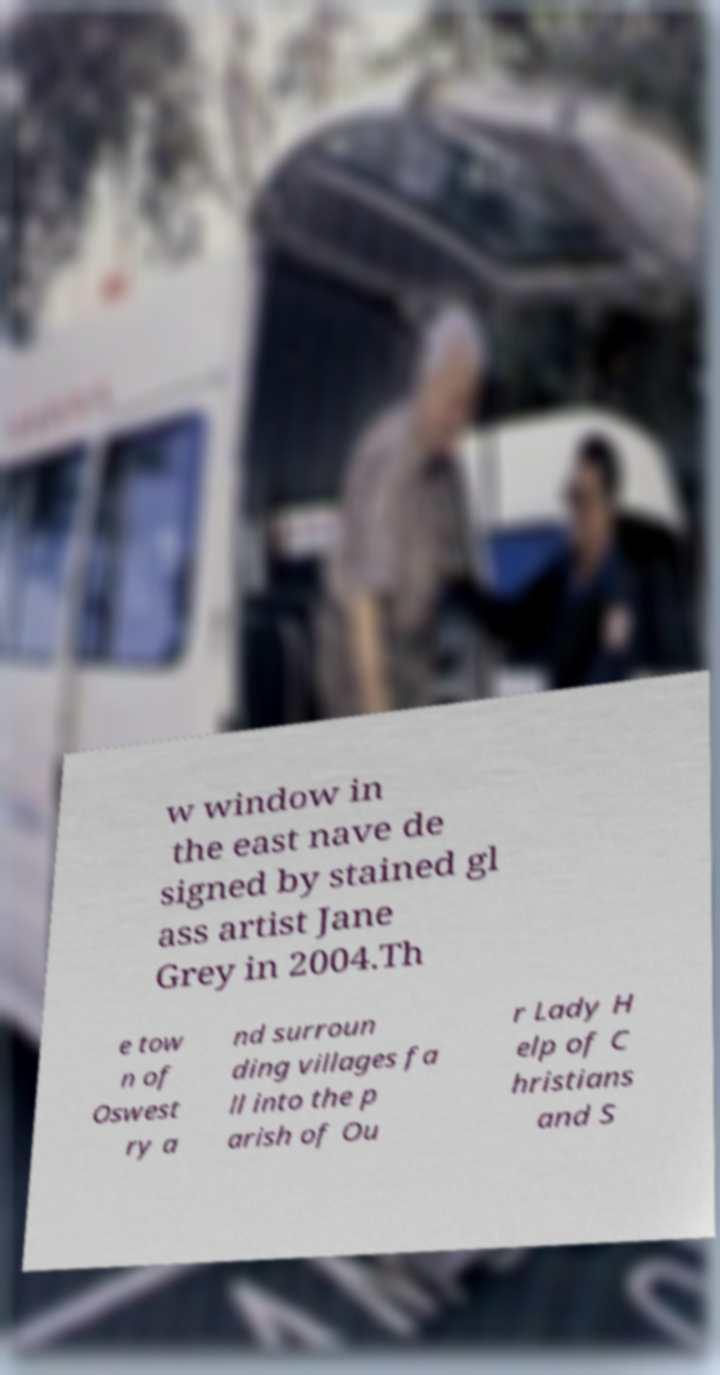What messages or text are displayed in this image? I need them in a readable, typed format. w window in the east nave de signed by stained gl ass artist Jane Grey in 2004.Th e tow n of Oswest ry a nd surroun ding villages fa ll into the p arish of Ou r Lady H elp of C hristians and S 